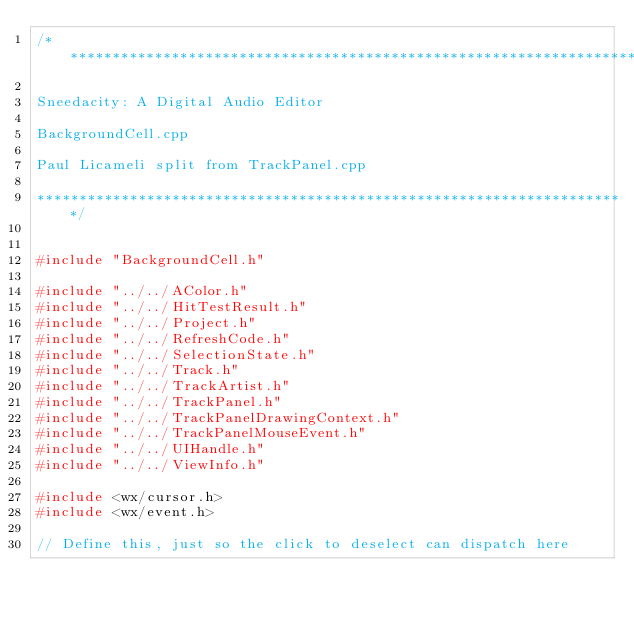<code> <loc_0><loc_0><loc_500><loc_500><_C++_>/**********************************************************************

Sneedacity: A Digital Audio Editor

BackgroundCell.cpp

Paul Licameli split from TrackPanel.cpp

**********************************************************************/


#include "BackgroundCell.h"

#include "../../AColor.h"
#include "../../HitTestResult.h"
#include "../../Project.h"
#include "../../RefreshCode.h"
#include "../../SelectionState.h"
#include "../../Track.h"
#include "../../TrackArtist.h"
#include "../../TrackPanel.h"
#include "../../TrackPanelDrawingContext.h"
#include "../../TrackPanelMouseEvent.h"
#include "../../UIHandle.h"
#include "../../ViewInfo.h"

#include <wx/cursor.h>
#include <wx/event.h>

// Define this, just so the click to deselect can dispatch here</code> 